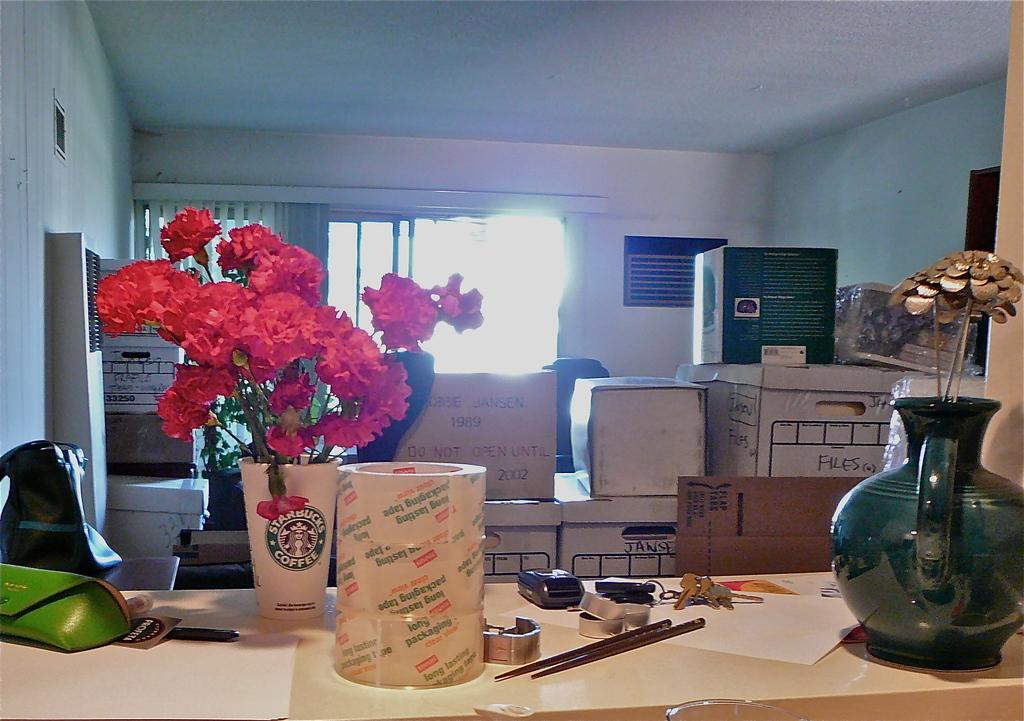Where is the setting of the image? The image is inside a room. What can be seen on the table in the image? There is a flower vase, papers, keys, and cups and glasses on the table. What is located behind the table in the image? There are cardboard boxes behind the table. Is there any source of natural light in the room? Yes, there is a window at the back of the room. How many thoughts can be seen floating around in the image? There are no thoughts visible in the image; it is a photograph of a room with various objects on a table and cardboard boxes behind it. 